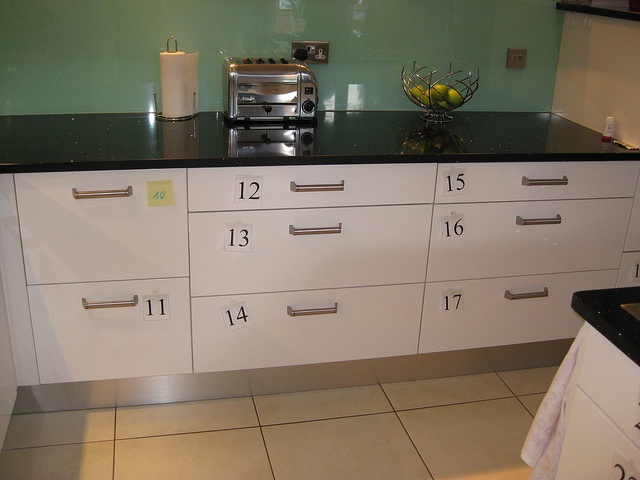Describe the objects in this image and their specific colors. I can see microwave in darkgreen, gray, and black tones and orange in darkgreen, black, and olive tones in this image. 